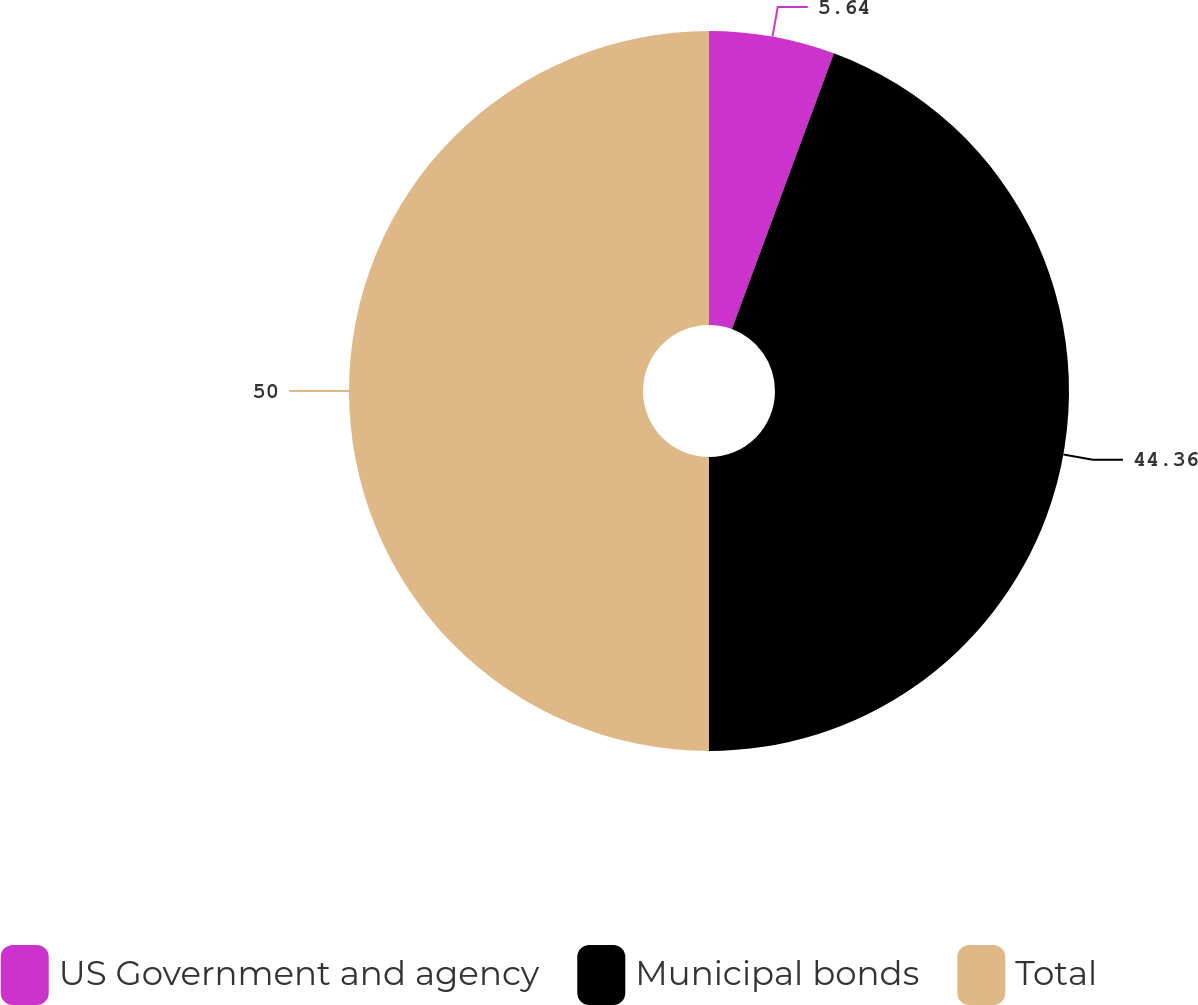Convert chart. <chart><loc_0><loc_0><loc_500><loc_500><pie_chart><fcel>US Government and agency<fcel>Municipal bonds<fcel>Total<nl><fcel>5.64%<fcel>44.36%<fcel>50.0%<nl></chart> 